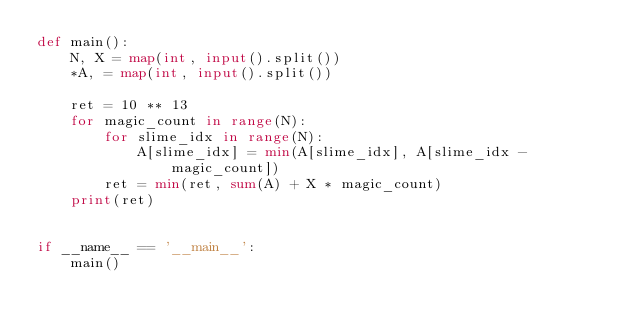Convert code to text. <code><loc_0><loc_0><loc_500><loc_500><_Python_>def main():
    N, X = map(int, input().split())
    *A, = map(int, input().split())

    ret = 10 ** 13
    for magic_count in range(N):
        for slime_idx in range(N):
            A[slime_idx] = min(A[slime_idx], A[slime_idx - magic_count])
        ret = min(ret, sum(A) + X * magic_count)
    print(ret)


if __name__ == '__main__':
    main()
</code> 